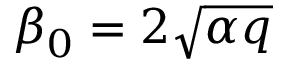Convert formula to latex. <formula><loc_0><loc_0><loc_500><loc_500>\beta _ { 0 } = 2 \sqrt { \alpha q }</formula> 